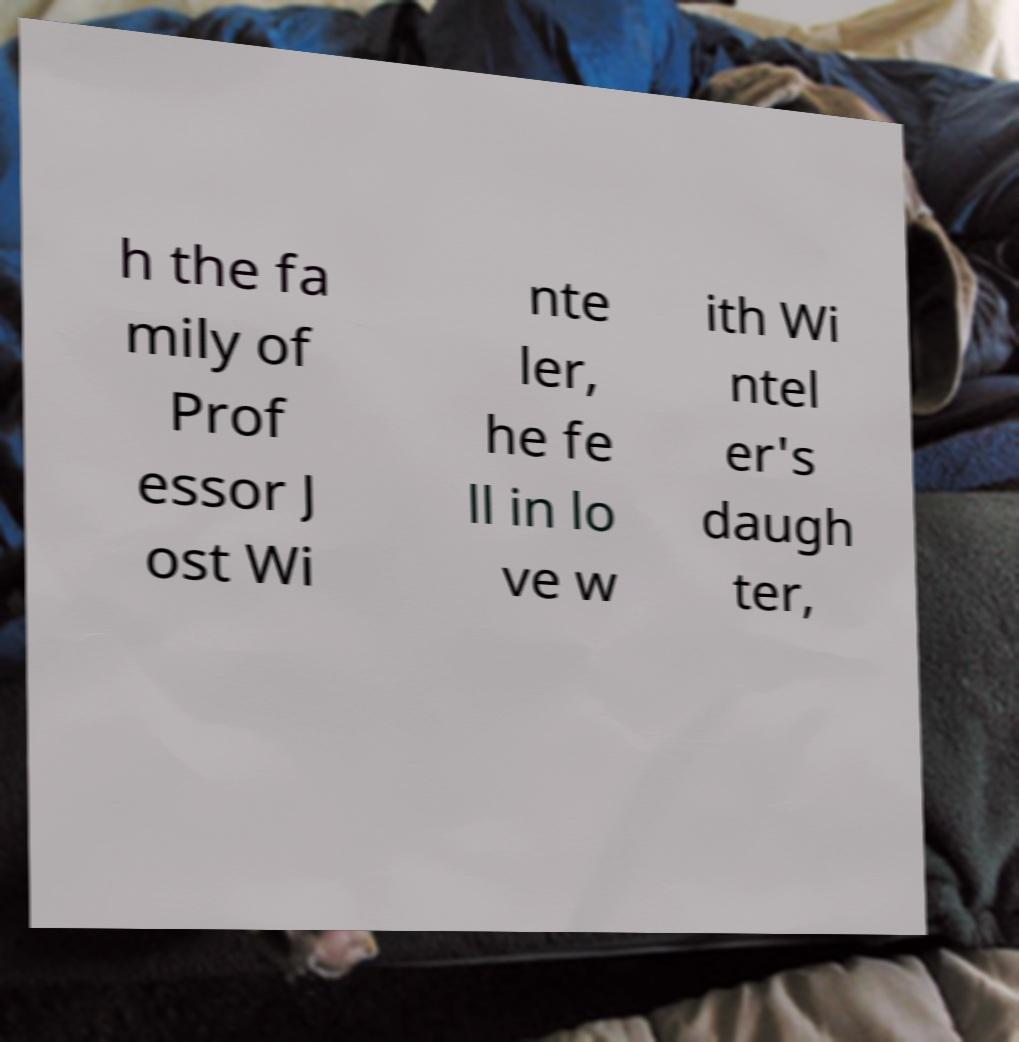Could you assist in decoding the text presented in this image and type it out clearly? h the fa mily of Prof essor J ost Wi nte ler, he fe ll in lo ve w ith Wi ntel er's daugh ter, 